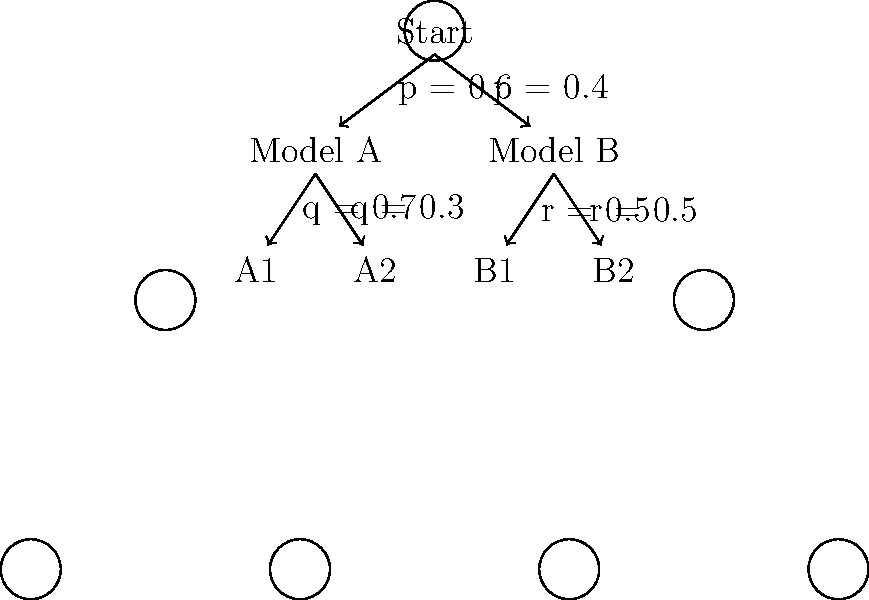In the process of reconstructing missing text in a damaged manuscript, you are using two statistical models (A and B) represented by the decision tree above. Given that Model A has a 60% chance of being selected and Model B has a 40% chance, what is the overall probability of reaching outcome A1? To solve this problem, we need to follow these steps:

1. Identify the path to outcome A1:
   Start → Model A → A1

2. Calculate the probability of each step in the path:
   - Probability of selecting Model A: $p = 0.6$
   - Probability of reaching A1 from Model A: $q = 0.7$

3. Multiply the probabilities along the path:
   $P(\text{A1}) = P(\text{Model A}) \times P(\text{A1 | Model A})$
   $P(\text{A1}) = 0.6 \times 0.7$

4. Perform the calculation:
   $P(\text{A1}) = 0.6 \times 0.7 = 0.42$

Therefore, the overall probability of reaching outcome A1 is 0.42 or 42%.
Answer: 0.42 